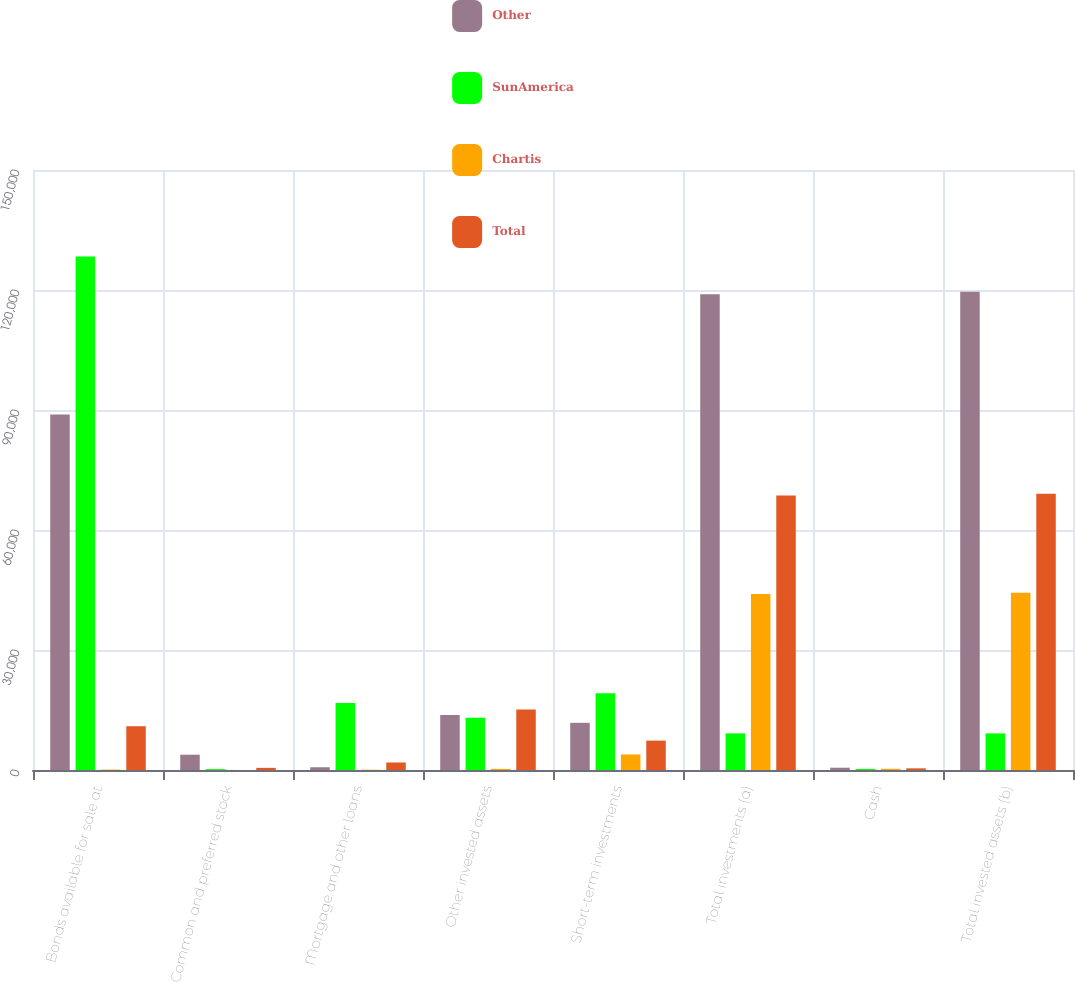Convert chart. <chart><loc_0><loc_0><loc_500><loc_500><stacked_bar_chart><ecel><fcel>Bonds available for sale at<fcel>Common and preferred stock<fcel>Mortgage and other loans<fcel>Other invested assets<fcel>Short-term investments<fcel>Total investments (a)<fcel>Cash<fcel>Total invested assets (b)<nl><fcel>Other<fcel>88904<fcel>3827<fcel>690<fcel>13743<fcel>11799<fcel>118963<fcel>572<fcel>119535<nl><fcel>SunAmerica<fcel>128347<fcel>218<fcel>16727<fcel>13069<fcel>19160<fcel>9145.5<fcel>270<fcel>9145.5<nl><fcel>Chartis<fcel>108<fcel>2<fcel>71<fcel>270<fcel>3878<fcel>44001<fcel>302<fcel>44303<nl><fcel>Total<fcel>10943<fcel>534<fcel>1879<fcel>15128<fcel>7348<fcel>68619<fcel>414<fcel>69033<nl></chart> 